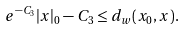<formula> <loc_0><loc_0><loc_500><loc_500>e ^ { - C _ { 3 } } | x | _ { 0 } - C _ { 3 } \leq d _ { w } ( x _ { 0 } , x ) .</formula> 